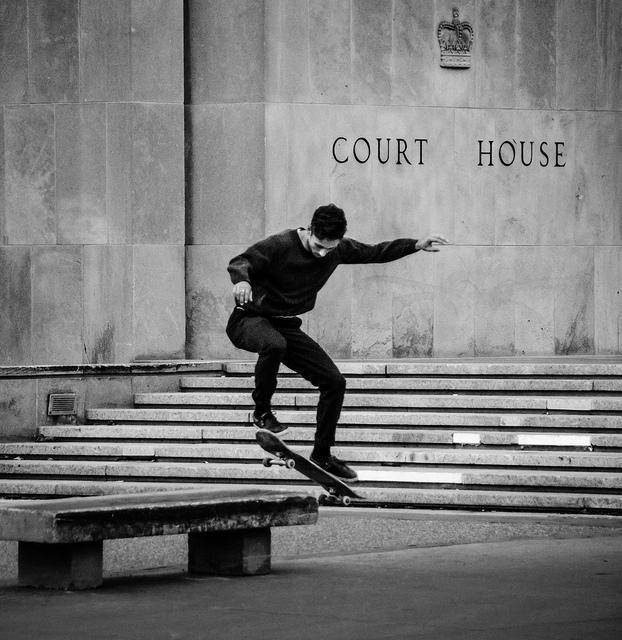In what type setting does the skateboarder skate here?
Choose the correct response and explain in the format: 'Answer: answer
Rationale: rationale.'
Options: Desert, farm, suburban, urban. Answer: urban.
Rationale: The skater is in front of the court house in a cement courtyard. 